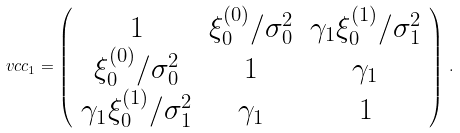<formula> <loc_0><loc_0><loc_500><loc_500>\ v c c _ { 1 } = \left ( \begin{array} { c c c } 1 & \xi _ { 0 } ^ { ( 0 ) } / \sigma _ { 0 } ^ { 2 } & \gamma _ { 1 } \xi _ { 0 } ^ { ( 1 ) } / \sigma _ { 1 } ^ { 2 } \\ \xi _ { 0 } ^ { ( 0 ) } / \sigma _ { 0 } ^ { 2 } & 1 & \gamma _ { 1 } \\ \gamma _ { 1 } \xi _ { 0 } ^ { ( 1 ) } / \sigma _ { 1 } ^ { 2 } & \gamma _ { 1 } & 1 \end{array} \right ) \, .</formula> 